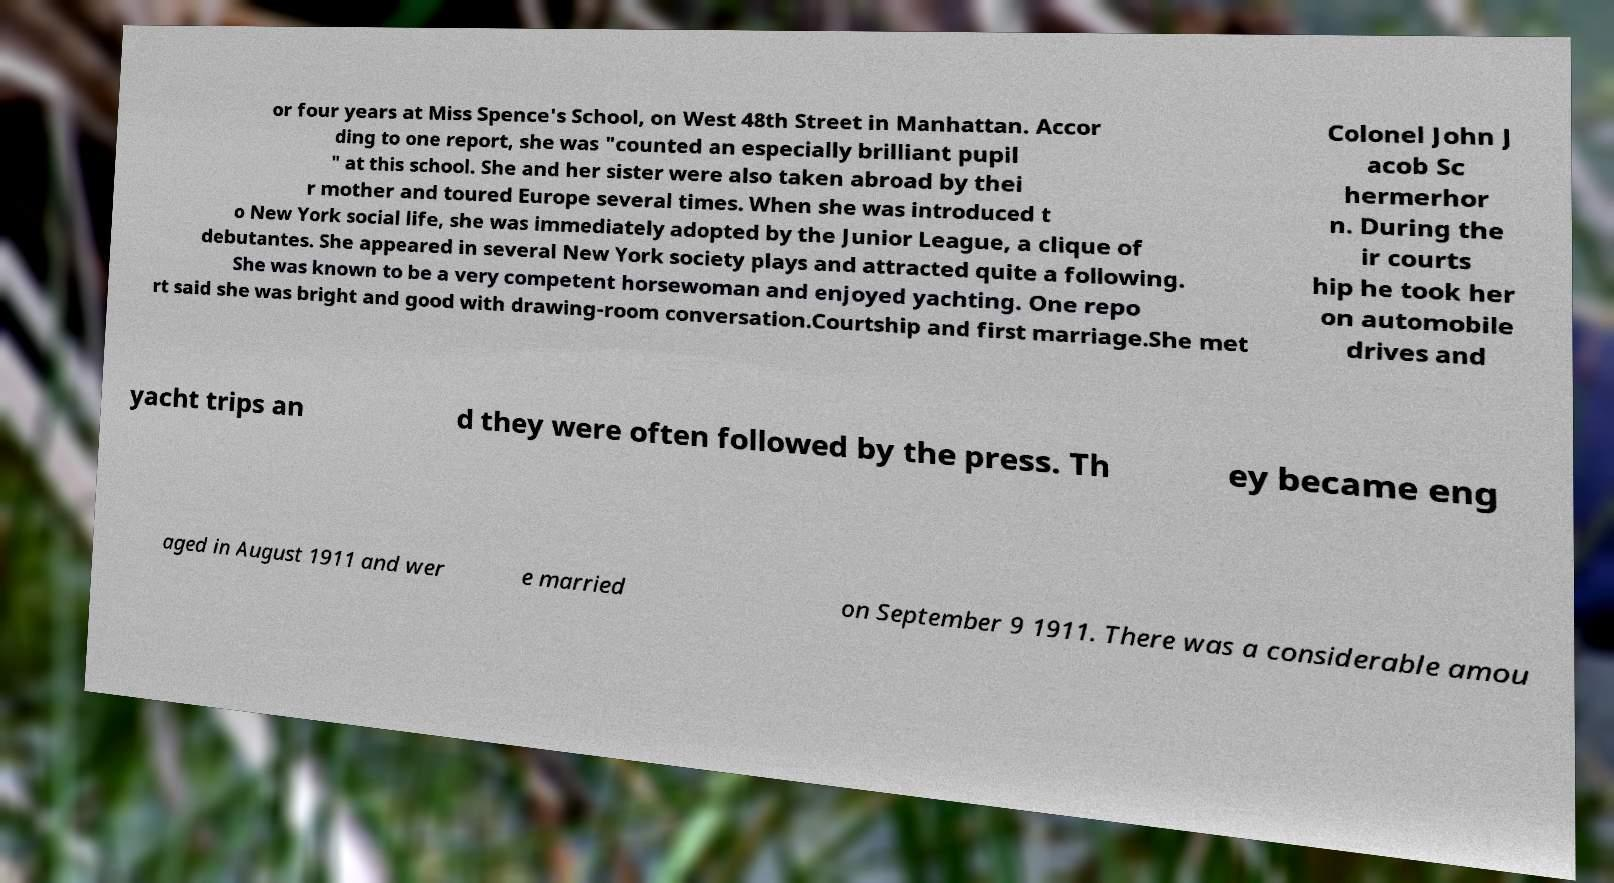Could you extract and type out the text from this image? or four years at Miss Spence's School, on West 48th Street in Manhattan. Accor ding to one report, she was "counted an especially brilliant pupil " at this school. She and her sister were also taken abroad by thei r mother and toured Europe several times. When she was introduced t o New York social life, she was immediately adopted by the Junior League, a clique of debutantes. She appeared in several New York society plays and attracted quite a following. She was known to be a very competent horsewoman and enjoyed yachting. One repo rt said she was bright and good with drawing-room conversation.Courtship and first marriage.She met Colonel John J acob Sc hermerhor n. During the ir courts hip he took her on automobile drives and yacht trips an d they were often followed by the press. Th ey became eng aged in August 1911 and wer e married on September 9 1911. There was a considerable amou 